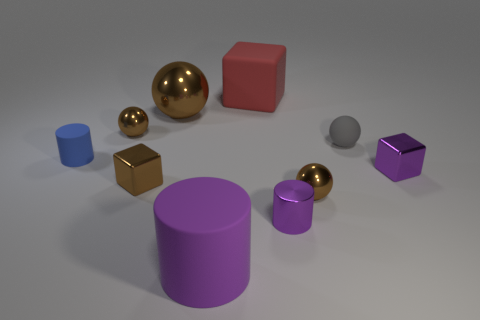Subtract all matte cylinders. How many cylinders are left? 1 Subtract all yellow balls. How many purple cylinders are left? 2 Subtract all gray balls. How many balls are left? 3 Subtract 1 cylinders. How many cylinders are left? 2 Subtract all balls. How many objects are left? 6 Subtract all metallic objects. Subtract all purple things. How many objects are left? 1 Add 2 rubber blocks. How many rubber blocks are left? 3 Add 9 large cyan metallic cubes. How many large cyan metallic cubes exist? 9 Subtract 0 blue spheres. How many objects are left? 10 Subtract all blue cubes. Subtract all purple balls. How many cubes are left? 3 